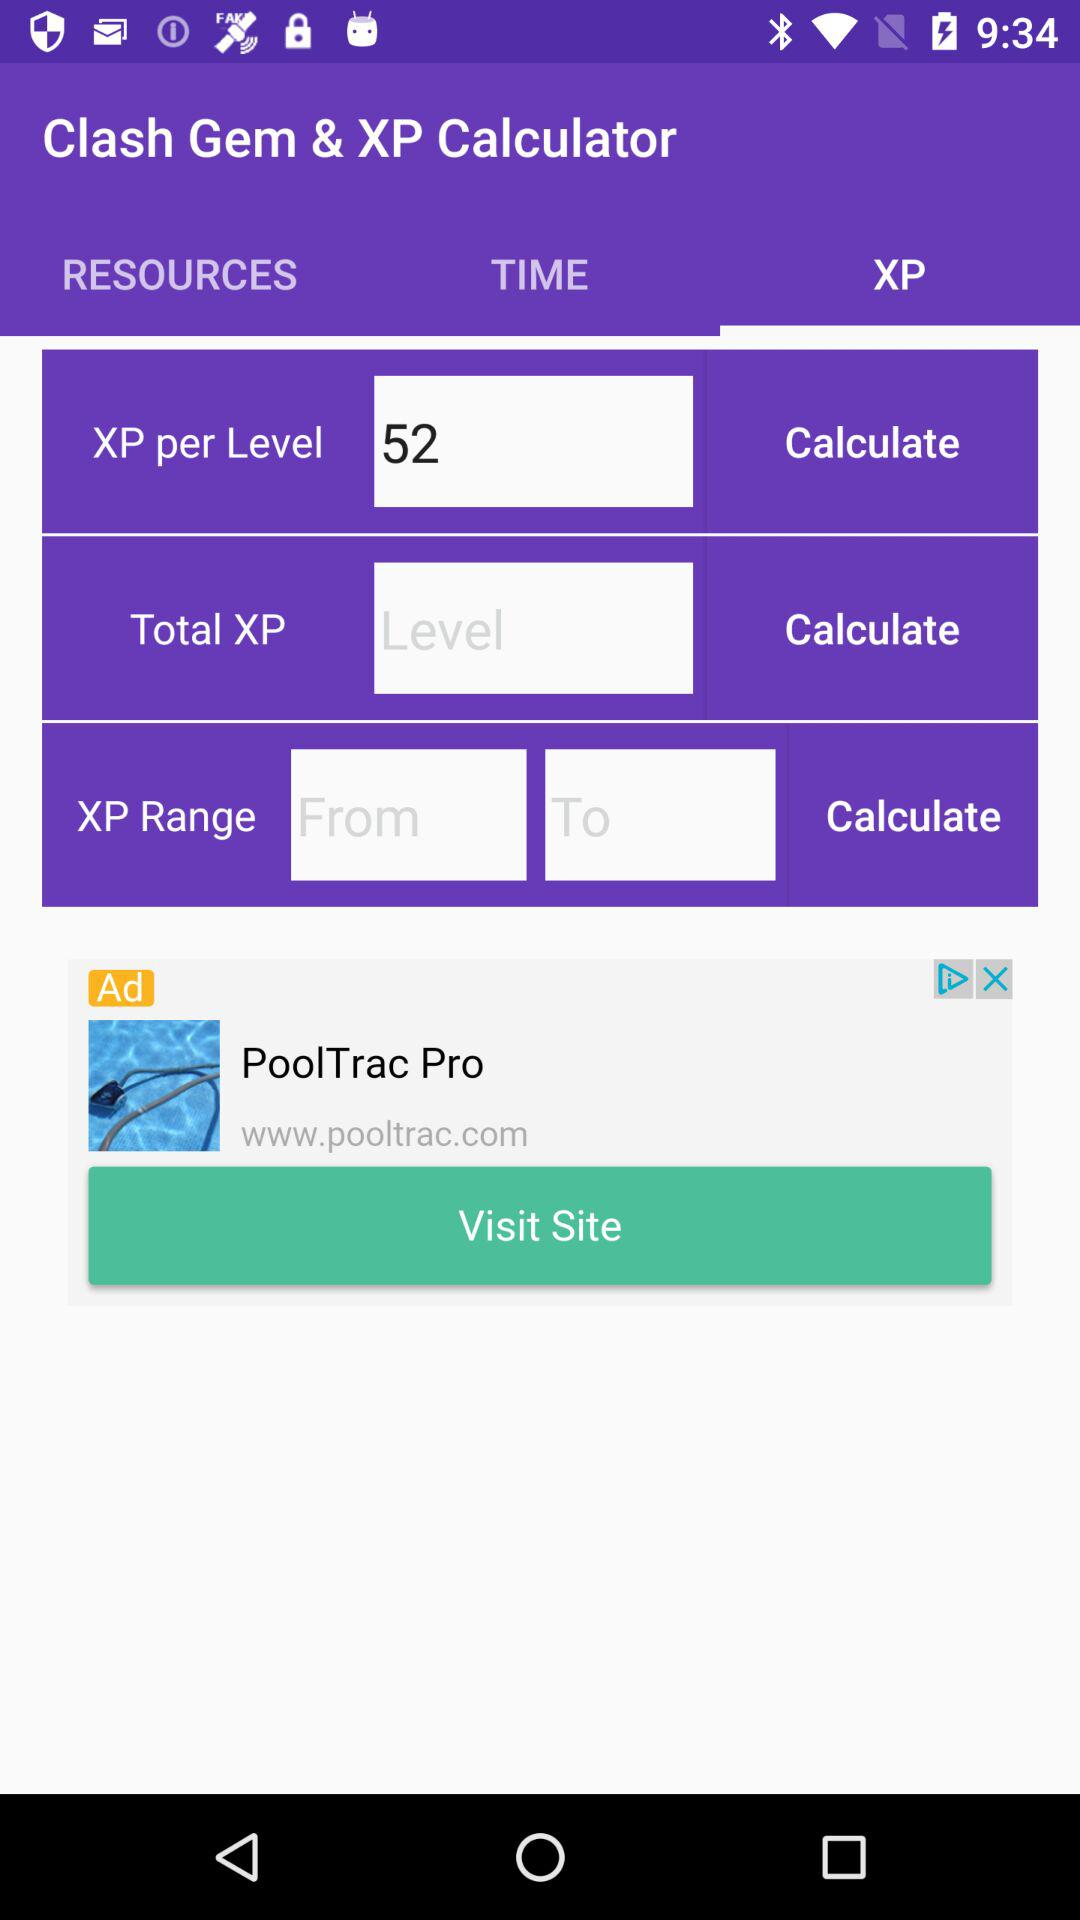What is the application name? The application name is "Clash Gem & XP Calculator". 